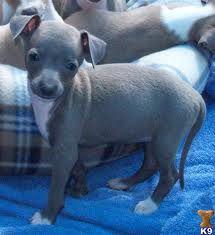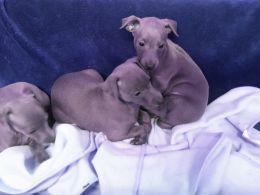The first image is the image on the left, the second image is the image on the right. Considering the images on both sides, is "A gray puppy with white paws is standing in front of another puppy in one image." valid? Answer yes or no. Yes. The first image is the image on the left, the second image is the image on the right. Evaluate the accuracy of this statement regarding the images: "There is at least one dog outside in the image on the left.". Is it true? Answer yes or no. No. 